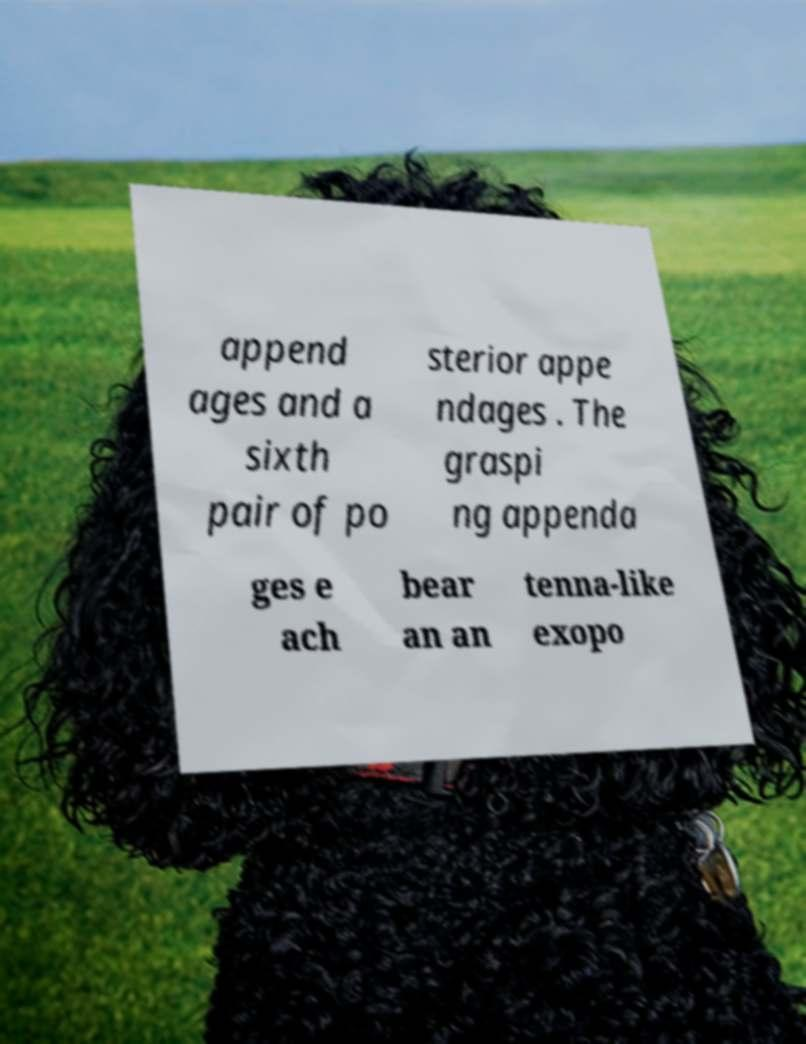Can you accurately transcribe the text from the provided image for me? append ages and a sixth pair of po sterior appe ndages . The graspi ng appenda ges e ach bear an an tenna-like exopo 